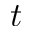<formula> <loc_0><loc_0><loc_500><loc_500>t</formula> 